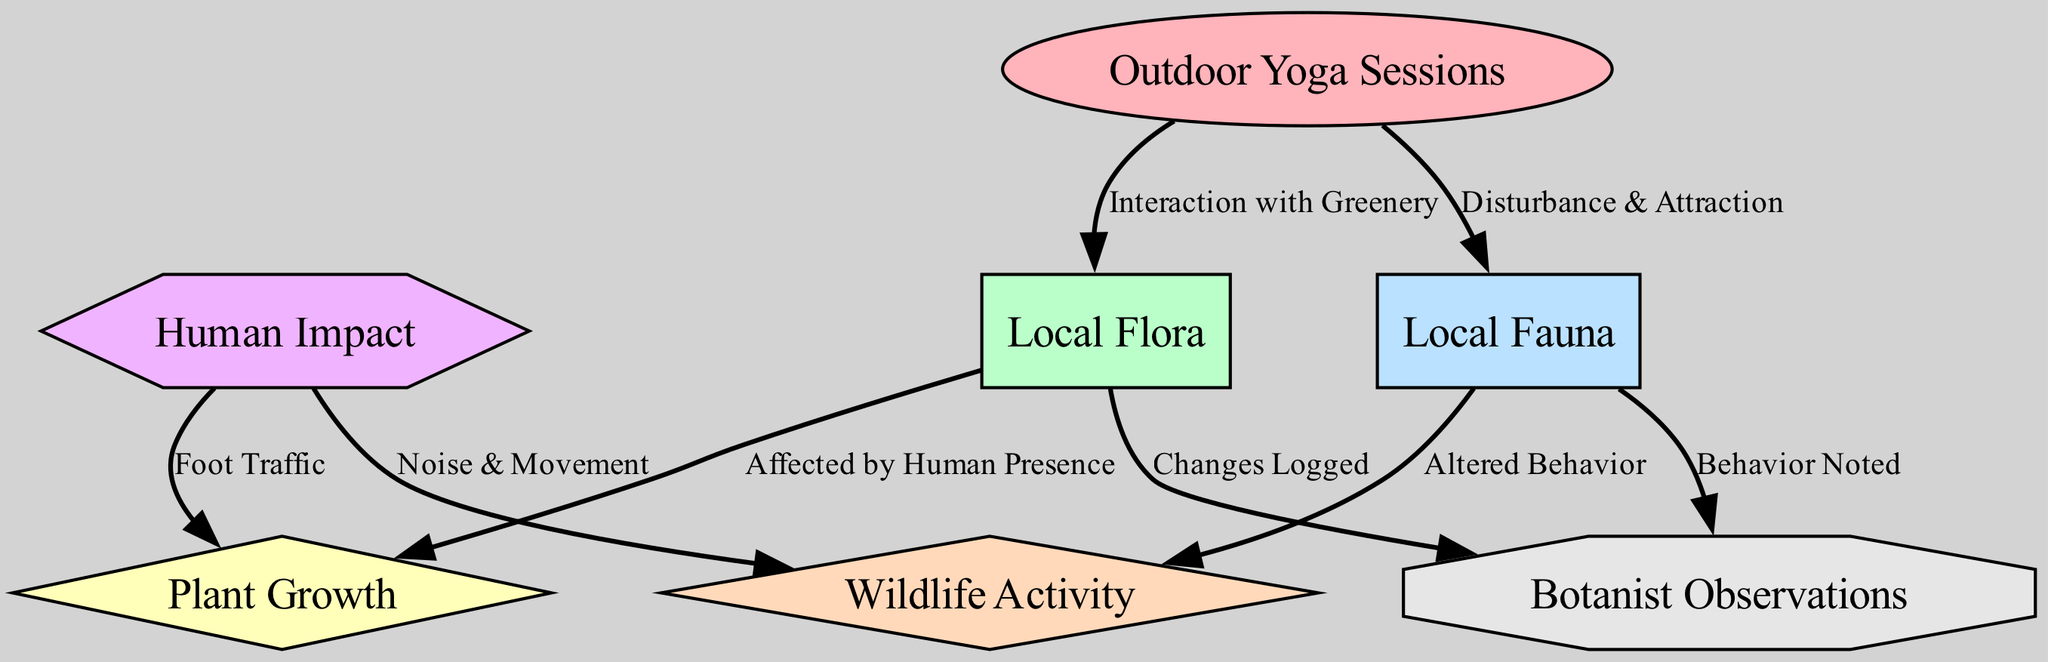What is the central node in the diagram? The central theme of the diagram is highlighted by the node labeled "Outdoor Yoga Sessions," which is connected to both local flora and fauna as primary areas of interaction. This node serves as a focal point and originates connections to other elements in the diagram.
Answer: Outdoor Yoga Sessions How many nodes are there in the diagram? The diagram consists of a total of seven nodes: Outdoor Yoga Sessions, Local Flora, Local Fauna, Plant Growth, Wildlife Activity, Human Impact, and Botanist Observations. These nodes represent different aspects of the interactions being studied.
Answer: 7 What relationship exists between yoga sessions and local flora? The edge connecting "Outdoor Yoga Sessions" to "Local Flora" is labeled "Interaction with Greenery," indicating that yoga sessions have a direct influence on or relationship with the local plants and greenery present in the environment.
Answer: Interaction with Greenery Which node represents the impact of human presence on plant growth? The connection established from "Local Flora" to "Plant Growth" with the label "Affected by Human Presence" indicates that the human activities, specifically through yoga sessions, influence the growth of plants in those areas.
Answer: Affected by Human Presence How does human impact affect wildlife activity? There are two connections from "Human Impact" to "Wildlife Activity" — one through "Noise & Movement" and another through "Foot Traffic." Both show that human activities during yoga sessions alter how wildlife behaves in that area, complicating their normal activities.
Answer: Noise & Movement, Foot Traffic What type of node is "Plant Growth"? The node "Plant Growth" is depicted as a diamond shape in the diagram, which typically represents a decision point or a result in flowchart diagrams. This indicates that it is influenced by interactions and behaviors rather than being a static entity.
Answer: Diamond How do observations relate to local flora and fauna? The "Botanist Observations" node has edges connecting to both "Local Flora" and "Local Fauna," labeled "Changes Logged" and "Behavior Noted," respectively. This indicates that observations involve monitoring and recording changes in both plants and animals as affected by outdoor yoga sessions.
Answer: Changes Logged, Behavior Noted 